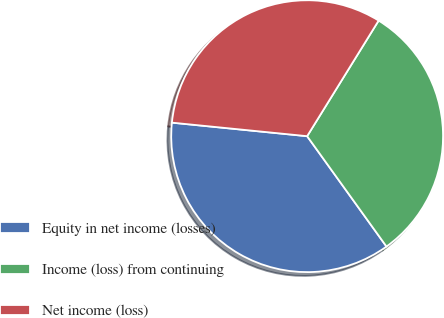<chart> <loc_0><loc_0><loc_500><loc_500><pie_chart><fcel>Equity in net income (losses)<fcel>Income (loss) from continuing<fcel>Net income (loss)<nl><fcel>36.51%<fcel>31.26%<fcel>32.23%<nl></chart> 